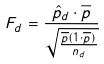Convert formula to latex. <formula><loc_0><loc_0><loc_500><loc_500>F _ { d } = \frac { \hat { p } _ { d } \cdot \overline { p } } { \sqrt { \frac { \overline { p } ( 1 \cdot \overline { p } ) } { n _ { d } } } }</formula> 